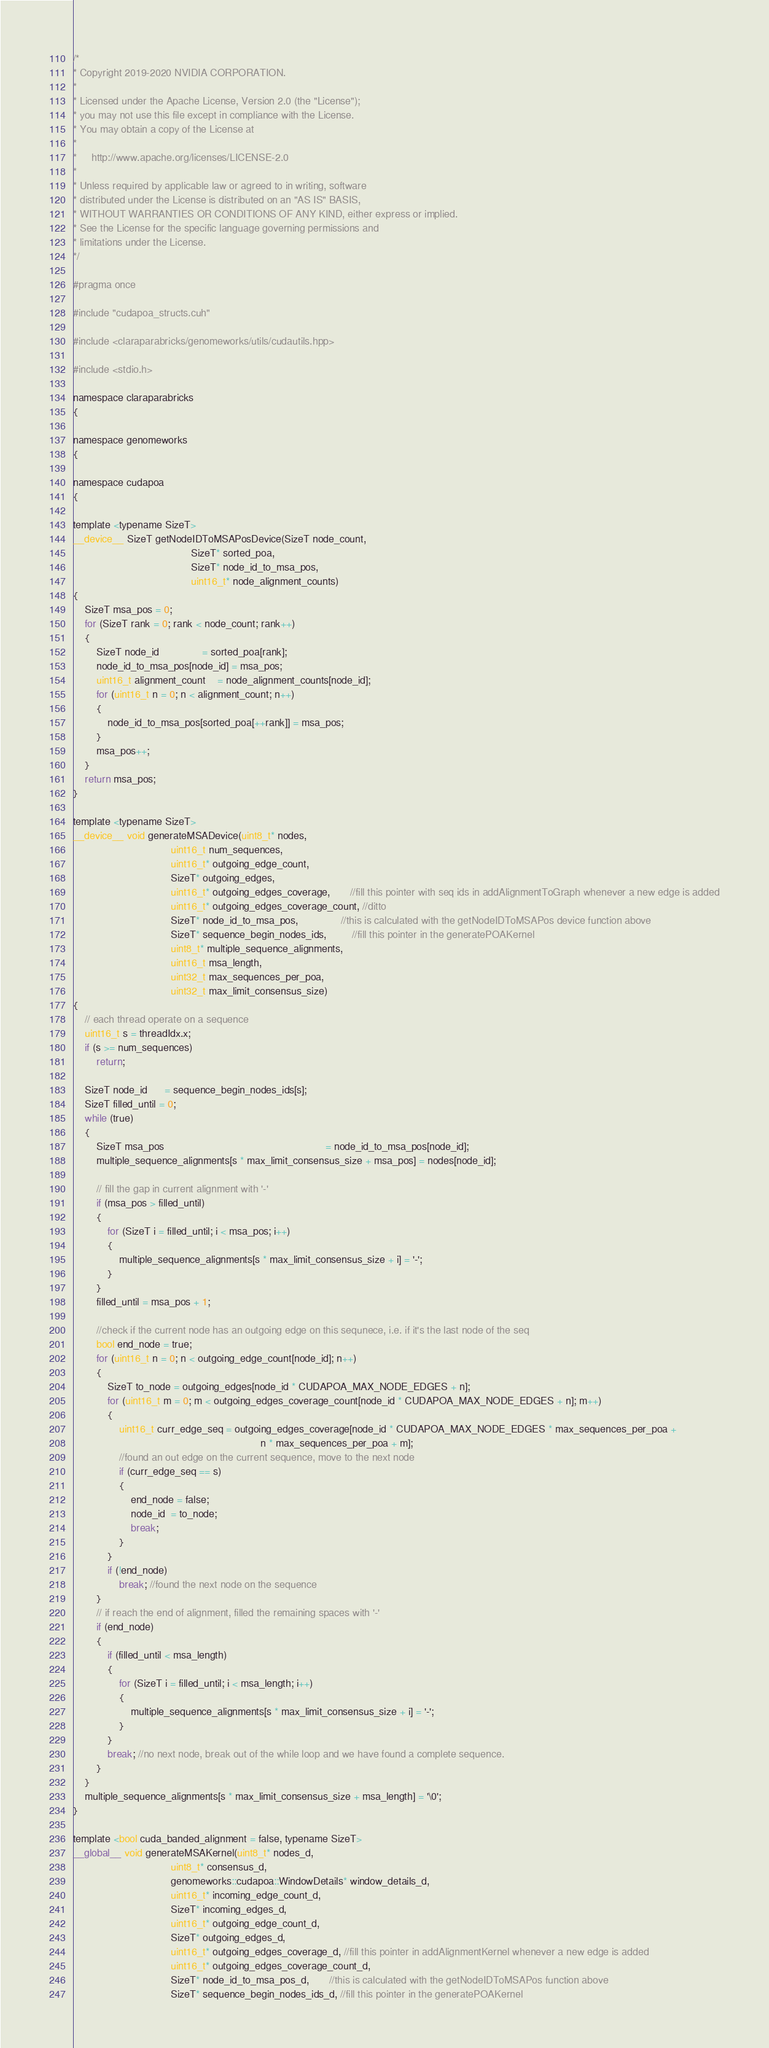Convert code to text. <code><loc_0><loc_0><loc_500><loc_500><_Cuda_>/*
* Copyright 2019-2020 NVIDIA CORPORATION.
*
* Licensed under the Apache License, Version 2.0 (the "License");
* you may not use this file except in compliance with the License.
* You may obtain a copy of the License at
*
*     http://www.apache.org/licenses/LICENSE-2.0
*
* Unless required by applicable law or agreed to in writing, software
* distributed under the License is distributed on an "AS IS" BASIS,
* WITHOUT WARRANTIES OR CONDITIONS OF ANY KIND, either express or implied.
* See the License for the specific language governing permissions and
* limitations under the License.
*/

#pragma once

#include "cudapoa_structs.cuh"

#include <claraparabricks/genomeworks/utils/cudautils.hpp>

#include <stdio.h>

namespace claraparabricks
{

namespace genomeworks
{

namespace cudapoa
{

template <typename SizeT>
__device__ SizeT getNodeIDToMSAPosDevice(SizeT node_count,
                                         SizeT* sorted_poa,
                                         SizeT* node_id_to_msa_pos,
                                         uint16_t* node_alignment_counts)
{
    SizeT msa_pos = 0;
    for (SizeT rank = 0; rank < node_count; rank++)
    {
        SizeT node_id               = sorted_poa[rank];
        node_id_to_msa_pos[node_id] = msa_pos;
        uint16_t alignment_count    = node_alignment_counts[node_id];
        for (uint16_t n = 0; n < alignment_count; n++)
        {
            node_id_to_msa_pos[sorted_poa[++rank]] = msa_pos;
        }
        msa_pos++;
    }
    return msa_pos;
}

template <typename SizeT>
__device__ void generateMSADevice(uint8_t* nodes,
                                  uint16_t num_sequences,
                                  uint16_t* outgoing_edge_count,
                                  SizeT* outgoing_edges,
                                  uint16_t* outgoing_edges_coverage,       //fill this pointer with seq ids in addAlignmentToGraph whenever a new edge is added
                                  uint16_t* outgoing_edges_coverage_count, //ditto
                                  SizeT* node_id_to_msa_pos,               //this is calculated with the getNodeIDToMSAPos device function above
                                  SizeT* sequence_begin_nodes_ids,         //fill this pointer in the generatePOAKernel
                                  uint8_t* multiple_sequence_alignments,
                                  uint16_t msa_length,
                                  uint32_t max_sequences_per_poa,
                                  uint32_t max_limit_consensus_size)
{
    // each thread operate on a sequence
    uint16_t s = threadIdx.x;
    if (s >= num_sequences)
        return;

    SizeT node_id      = sequence_begin_nodes_ids[s];
    SizeT filled_until = 0;
    while (true)
    {
        SizeT msa_pos                                                        = node_id_to_msa_pos[node_id];
        multiple_sequence_alignments[s * max_limit_consensus_size + msa_pos] = nodes[node_id];

        // fill the gap in current alignment with '-'
        if (msa_pos > filled_until)
        {
            for (SizeT i = filled_until; i < msa_pos; i++)
            {
                multiple_sequence_alignments[s * max_limit_consensus_size + i] = '-';
            }
        }
        filled_until = msa_pos + 1;

        //check if the current node has an outgoing edge on this sequnece, i.e. if it's the last node of the seq
        bool end_node = true;
        for (uint16_t n = 0; n < outgoing_edge_count[node_id]; n++)
        {
            SizeT to_node = outgoing_edges[node_id * CUDAPOA_MAX_NODE_EDGES + n];
            for (uint16_t m = 0; m < outgoing_edges_coverage_count[node_id * CUDAPOA_MAX_NODE_EDGES + n]; m++)
            {
                uint16_t curr_edge_seq = outgoing_edges_coverage[node_id * CUDAPOA_MAX_NODE_EDGES * max_sequences_per_poa +
                                                                 n * max_sequences_per_poa + m];
                //found an out edge on the current sequence, move to the next node
                if (curr_edge_seq == s)
                {
                    end_node = false;
                    node_id  = to_node;
                    break;
                }
            }
            if (!end_node)
                break; //found the next node on the sequence
        }
        // if reach the end of alignment, filled the remaining spaces with '-'
        if (end_node)
        {
            if (filled_until < msa_length)
            {
                for (SizeT i = filled_until; i < msa_length; i++)
                {
                    multiple_sequence_alignments[s * max_limit_consensus_size + i] = '-';
                }
            }
            break; //no next node, break out of the while loop and we have found a complete sequence.
        }
    }
    multiple_sequence_alignments[s * max_limit_consensus_size + msa_length] = '\0';
}

template <bool cuda_banded_alignment = false, typename SizeT>
__global__ void generateMSAKernel(uint8_t* nodes_d,
                                  uint8_t* consensus_d,
                                  genomeworks::cudapoa::WindowDetails* window_details_d,
                                  uint16_t* incoming_edge_count_d,
                                  SizeT* incoming_edges_d,
                                  uint16_t* outgoing_edge_count_d,
                                  SizeT* outgoing_edges_d,
                                  uint16_t* outgoing_edges_coverage_d, //fill this pointer in addAlignmentKernel whenever a new edge is added
                                  uint16_t* outgoing_edges_coverage_count_d,
                                  SizeT* node_id_to_msa_pos_d,       //this is calculated with the getNodeIDToMSAPos function above
                                  SizeT* sequence_begin_nodes_ids_d, //fill this pointer in the generatePOAKernel</code> 